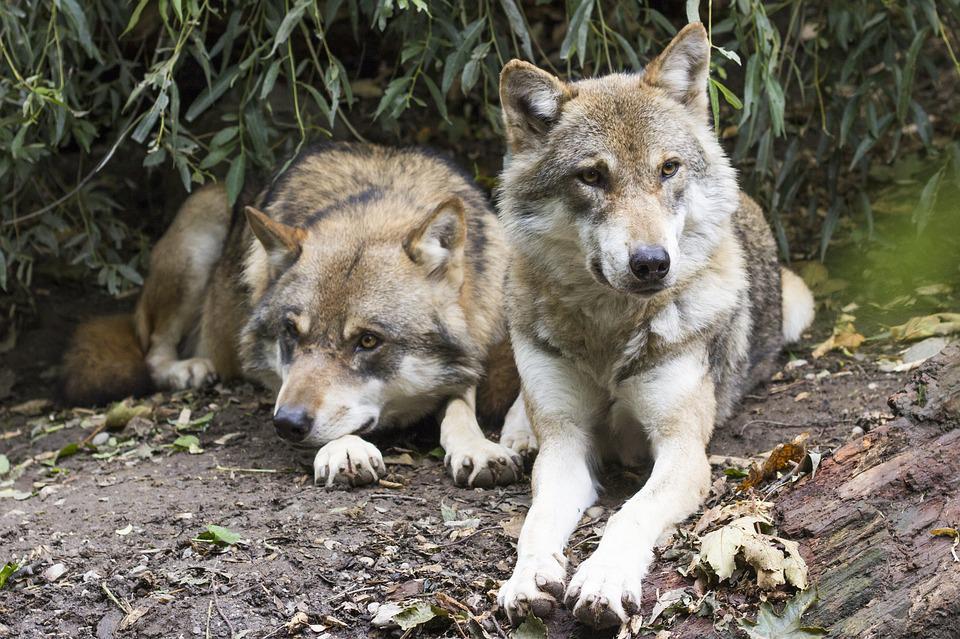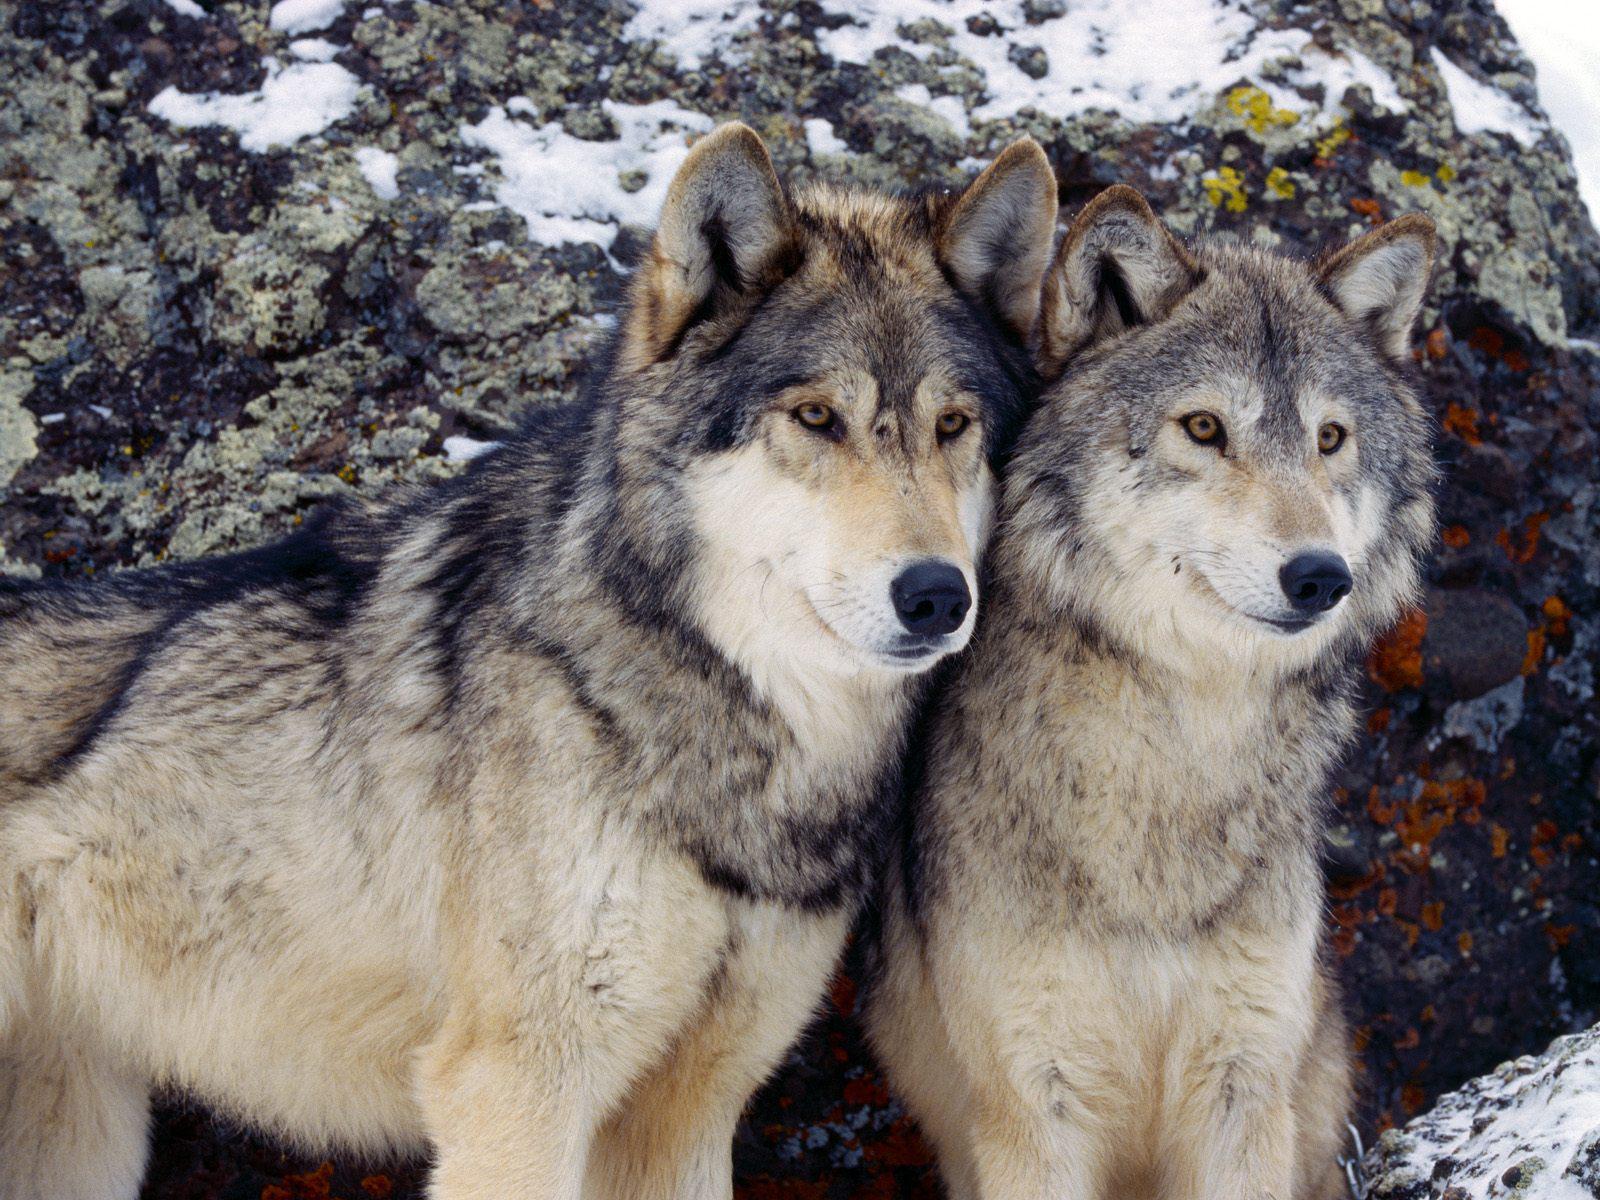The first image is the image on the left, the second image is the image on the right. Considering the images on both sides, is "There are at most 3 wolves." valid? Answer yes or no. No. The first image is the image on the left, the second image is the image on the right. Assess this claim about the two images: "You can clearly see there are more than three wolves or dogs.". Correct or not? Answer yes or no. Yes. 